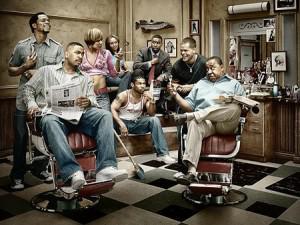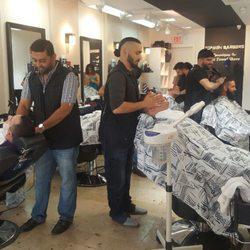The first image is the image on the left, the second image is the image on the right. Examine the images to the left and right. Is the description "People are getting their haircut in exactly one image." accurate? Answer yes or no. Yes. The first image is the image on the left, the second image is the image on the right. Considering the images on both sides, is "Nobody is getting a haircut in the left image, but someone is in the right image." valid? Answer yes or no. Yes. 